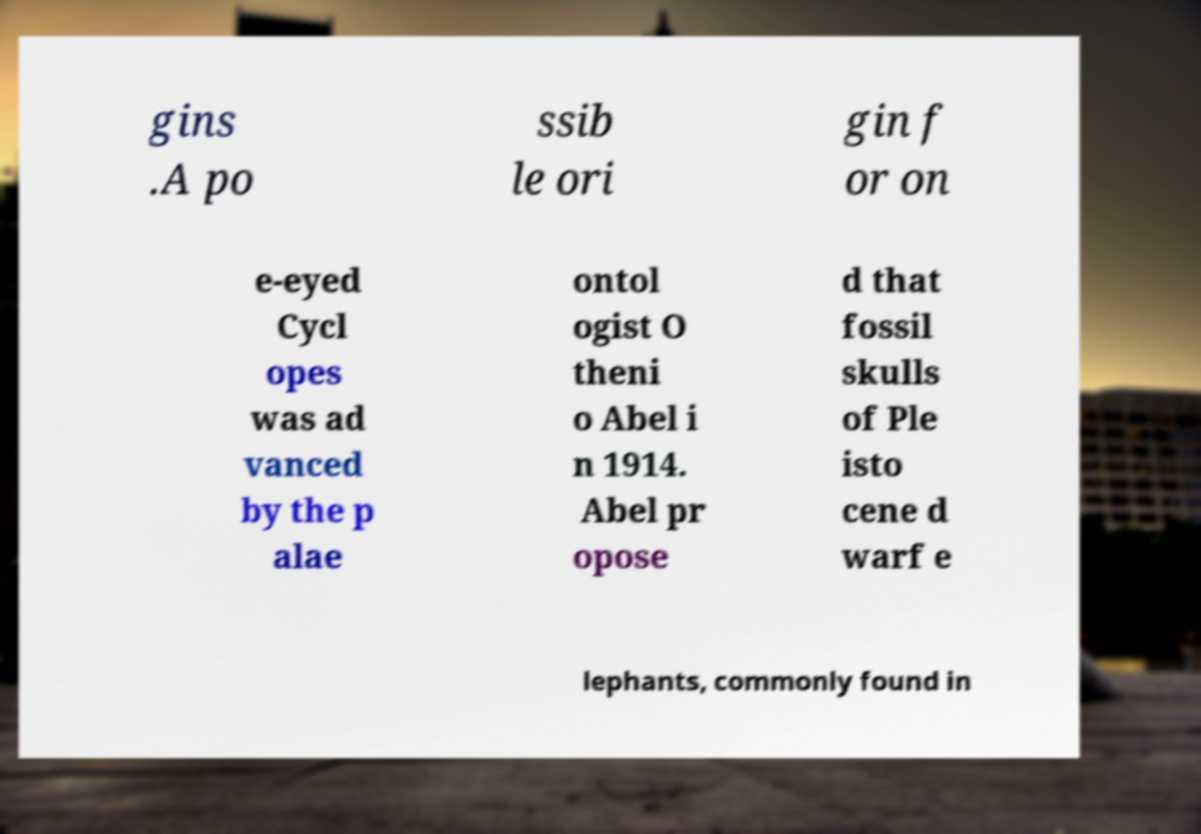Could you assist in decoding the text presented in this image and type it out clearly? gins .A po ssib le ori gin f or on e-eyed Cycl opes was ad vanced by the p alae ontol ogist O theni o Abel i n 1914. Abel pr opose d that fossil skulls of Ple isto cene d warf e lephants, commonly found in 